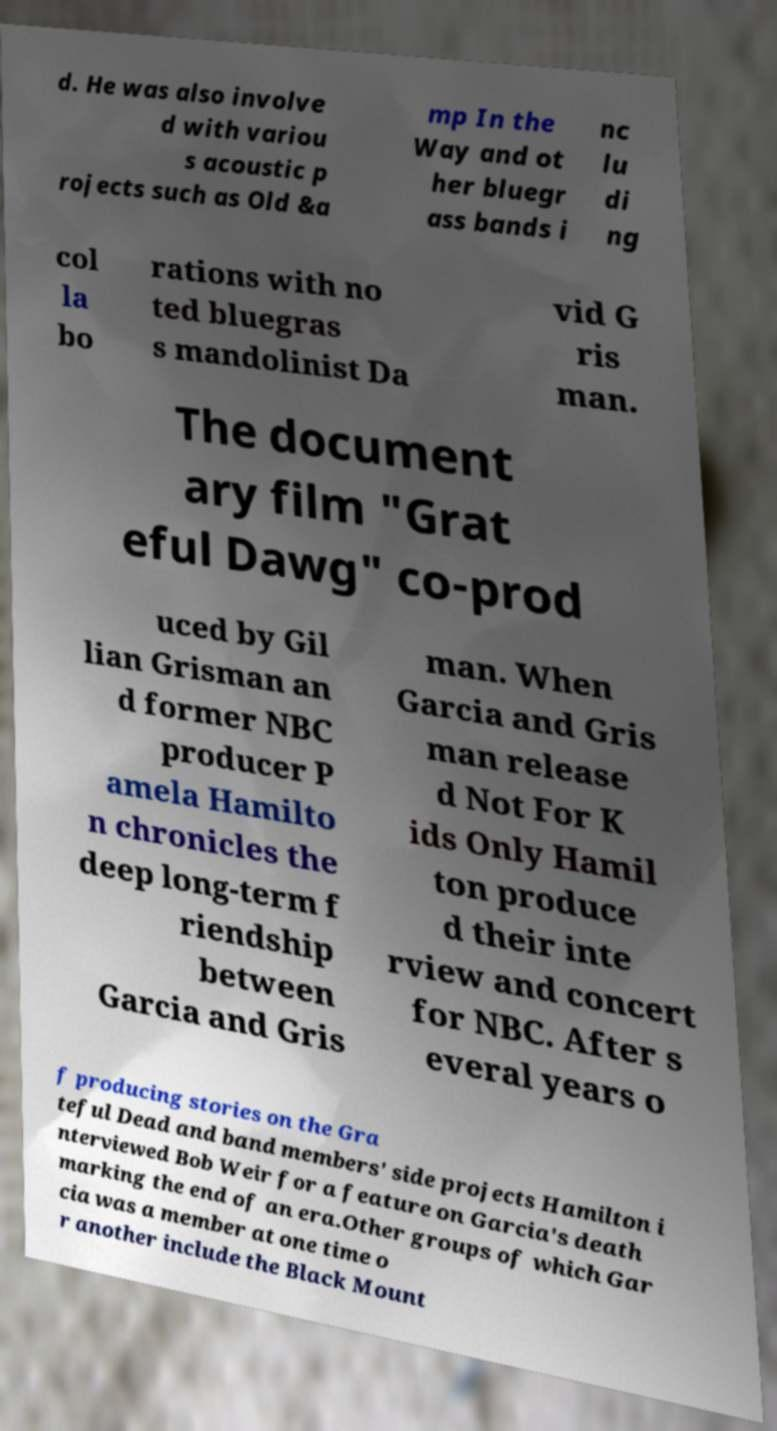Please identify and transcribe the text found in this image. d. He was also involve d with variou s acoustic p rojects such as Old &a mp In the Way and ot her bluegr ass bands i nc lu di ng col la bo rations with no ted bluegras s mandolinist Da vid G ris man. The document ary film "Grat eful Dawg" co-prod uced by Gil lian Grisman an d former NBC producer P amela Hamilto n chronicles the deep long-term f riendship between Garcia and Gris man. When Garcia and Gris man release d Not For K ids Only Hamil ton produce d their inte rview and concert for NBC. After s everal years o f producing stories on the Gra teful Dead and band members' side projects Hamilton i nterviewed Bob Weir for a feature on Garcia's death marking the end of an era.Other groups of which Gar cia was a member at one time o r another include the Black Mount 